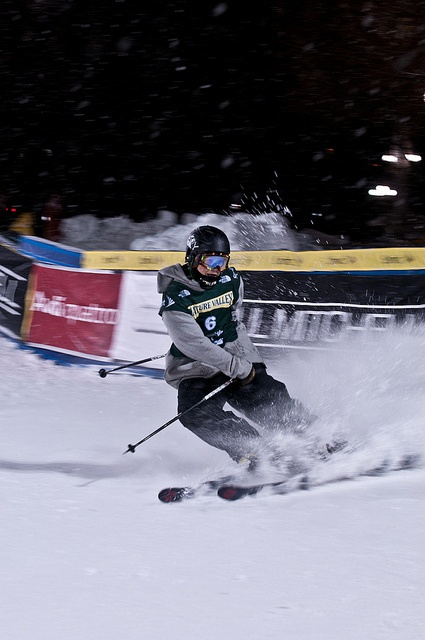Describe the objects in this image and their specific colors. I can see people in black, darkgray, and gray tones and skis in black, darkgray, lavender, and gray tones in this image. 